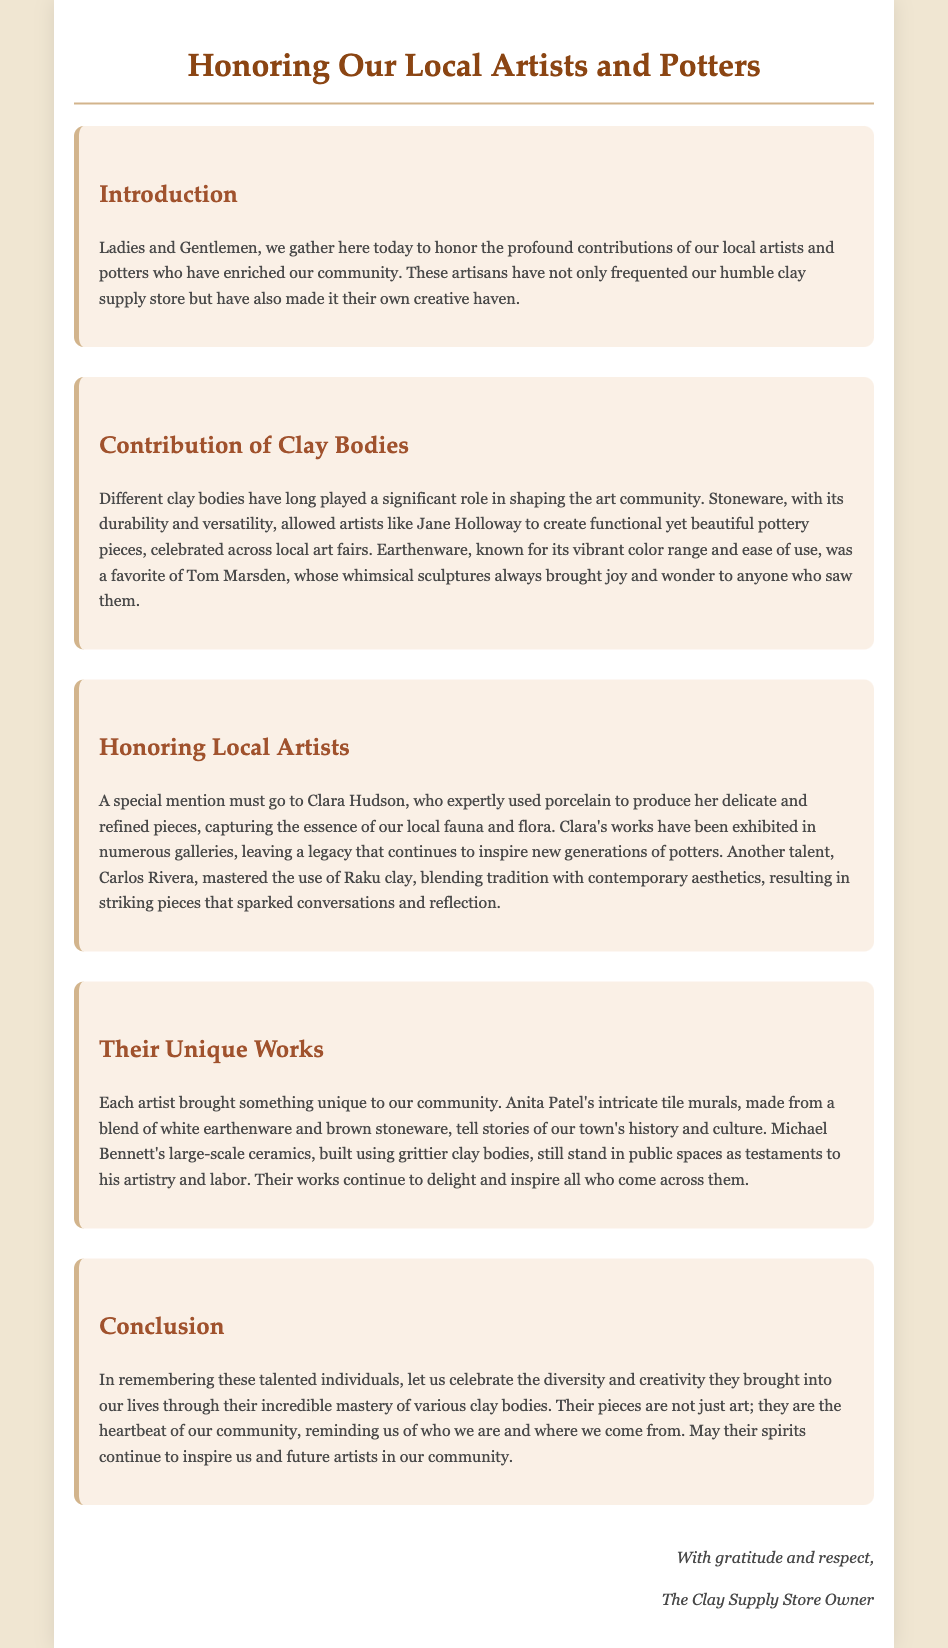what is the title of the document? The title of the document is located in the HTML head section.
Answer: Honoring Our Local Artists and Potters who is mentioned as a master of Raku clay? This information is found in the section honoring local artists, specifically about Carlos Rivera.
Answer: Carlos Rivera what type of clay did Jane Holloway use? The document describes the materials used by various artists, including Jane Holloway.
Answer: Stoneware how did Tom Marsden's sculptures make people feel? This information is inferred from the description of Tom Marsden's work in the contributions of clay bodies section.
Answer: Joy and wonder what are Anita Patel's murals made from? The document specifically mentions the materials used by Anita Patel for her works.
Answer: White earthenware and brown stoneware which artist focused on porcelain? The section on honoring local artists names the artist associated with porcelain.
Answer: Clara Hudson what is the essence captured by Clara Hudson's works? This is revealed in the description of Clara Hudson's art in the eulogy.
Answer: Local fauna and flora what do Michael Bennett's sculptures represent? This can be inferred from the description of his large-scale ceramics in the document.
Answer: Artistry and labor how does the conclusion describe the artists' pieces? This part of the document provides a summary of how the works of the artists are characterized.
Answer: Heartbeat of our community 